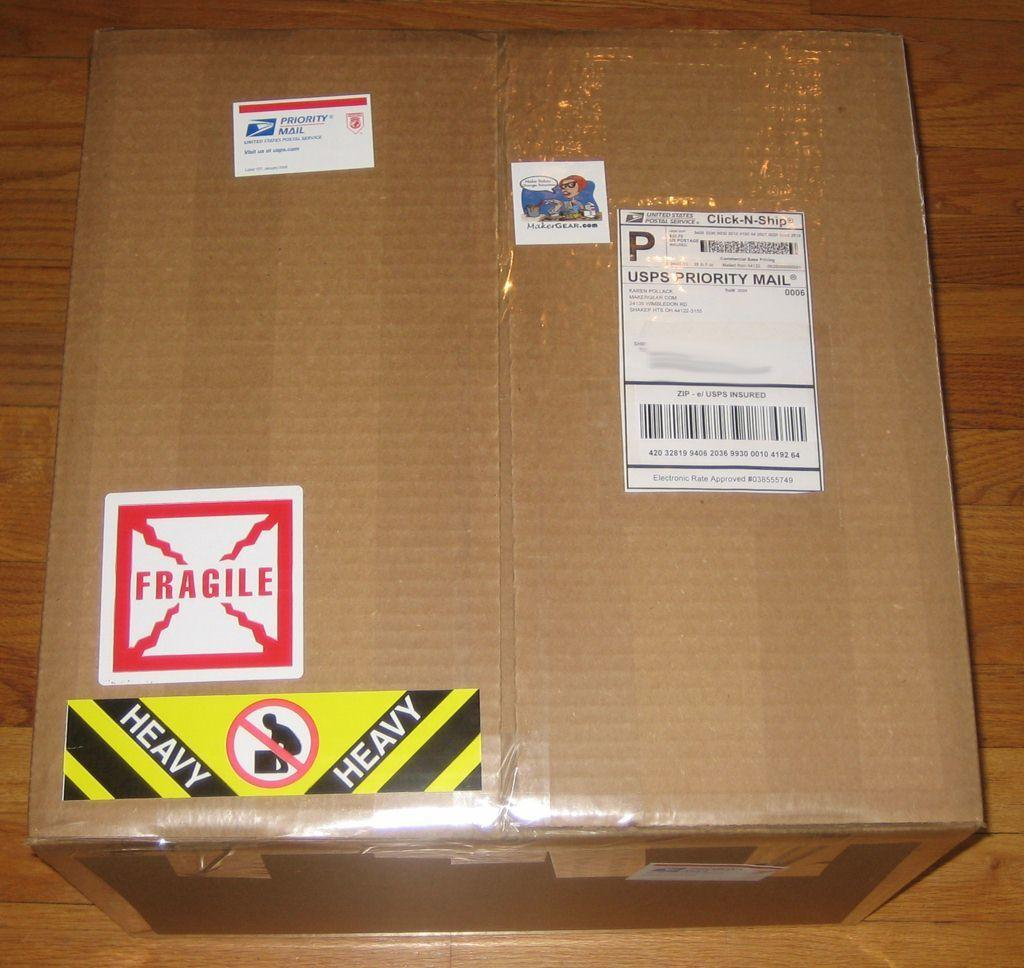<image>
Offer a succinct explanation of the picture presented. A fragile sticker is on a box that has a shipping label. 